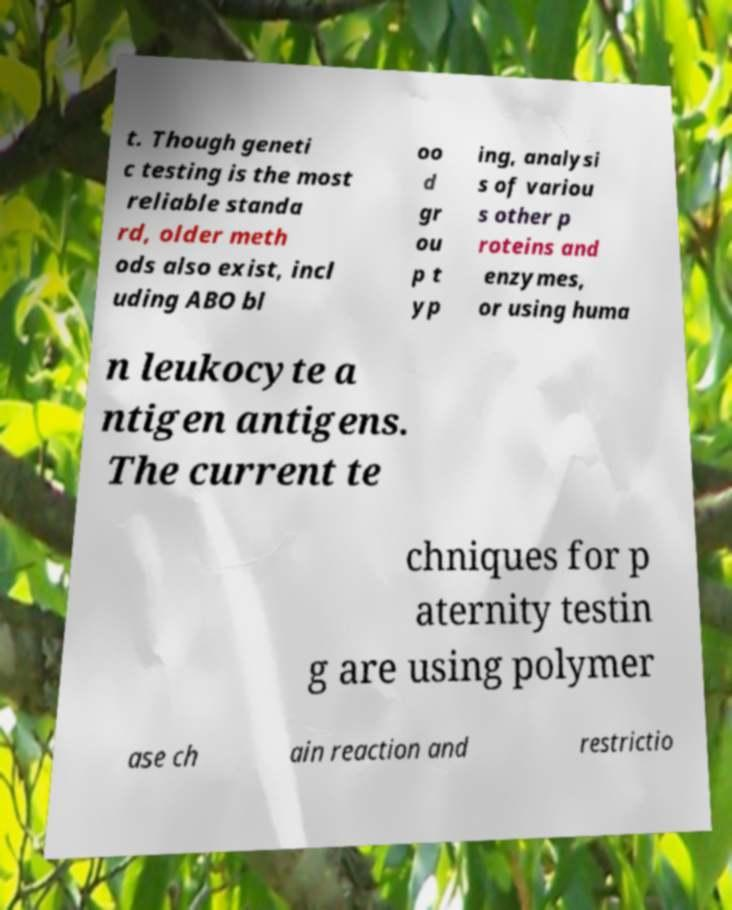Could you assist in decoding the text presented in this image and type it out clearly? t. Though geneti c testing is the most reliable standa rd, older meth ods also exist, incl uding ABO bl oo d gr ou p t yp ing, analysi s of variou s other p roteins and enzymes, or using huma n leukocyte a ntigen antigens. The current te chniques for p aternity testin g are using polymer ase ch ain reaction and restrictio 